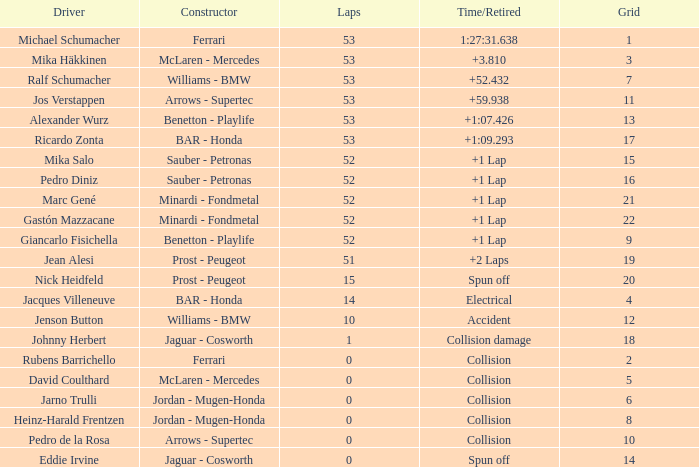How many laps did Ricardo Zonta have? 53.0. 